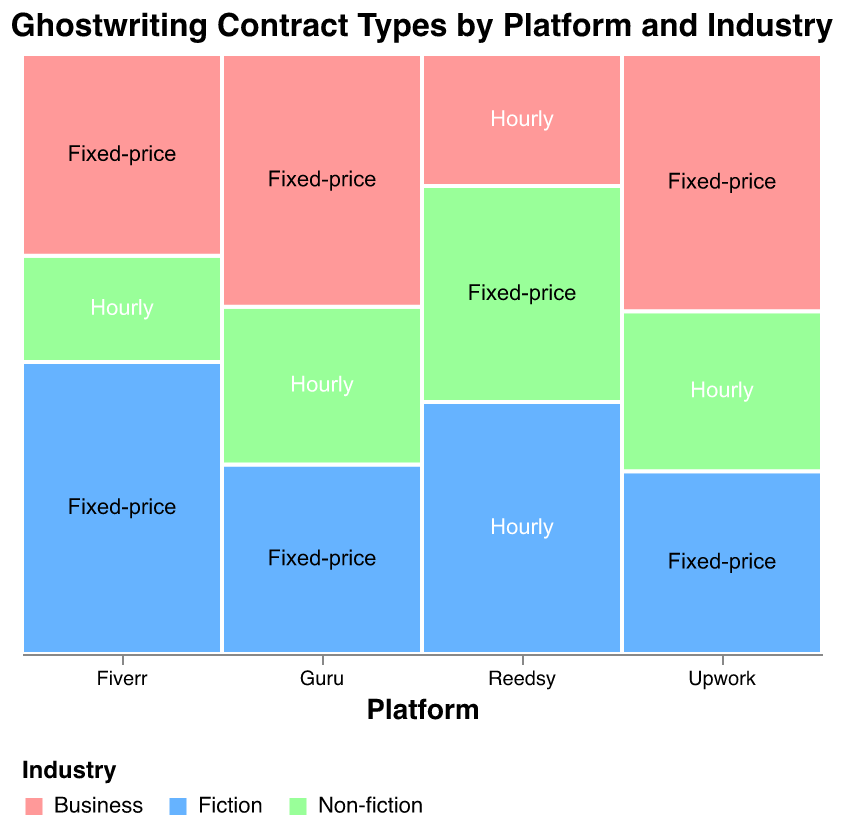Which platform has the highest number of Fixed-price contracts in the Fiction industry? Look at the rectangles representing Fixed-price contracts within the Fiction industry for each platform. Fiverr has the largest rectangle.
Answer: Fiverr Which industry on Upwork has the highest frequency of Fixed-price contracts? Compare the rectangles for each industry within Upwork that represents Fixed-price contracts. The Business industry has the largest Fixed-price rectangle.
Answer: Business Do any platforms predominantly use Hourly contracts in the Business industry? Check the rectangles corresponding to Hourly contracts within the Business industry for each platform. None of the platforms predominantly use Hourly contracts in the Business industry; they all use Fixed-price.
Answer: No What is the total frequency of Fixed-price contracts in the Fiction industry across all platforms? Add the frequencies for Fixed-price contracts in the Fiction industry for Upwork (32), Fiverr (55), and Guru (30). 32 + 55 + 30 = 117
Answer: 117 Which platform has the most balanced distribution of contract types across different industries in terms of visual appearance? Look at each platform and compare the sizes of the rectangles within. Reedsy appears to have a more balanced distribution between Hourly and Fixed-price across different industries.
Answer: Reedsy How does the frequency of Fixed-price contracts in Business on Fiverr compare to the same type of contract on Upwork? Compare the size of the Fixed-price rectangle in the Business industry between Fiverr and Upwork. Fiverr has a smaller rectangle (38) compared to Upwork (45).
Answer: Upwork has more Which platform and industry combination has the lowest frequency for Hourly contracts? Look at all the Hourly contracts and compare their sizes to determine the smallest. Fiverr's Non-fiction Hourly contract has the smallest rectangle with a frequency of 20.
Answer: Fiverr, Non-fiction Are Non-fiction contracts more frequently Hourly or Fixed-price across all platforms? Compare the total frequencies of Hourly and Fixed-price contracts in the Non-fiction industry. Non-fiction has 28 (Upwork) + 20 (Fiverr) + 25 (Guru) = 73 for Hourly, and 36 (Reedsy) for Fixed-price, so Hourly is more frequent.
Answer: Hourly Which platform uses Hourly contracts the least in the Fiction industry? Compare the Hourly contracts in the Fiction industry across platforms. Guru and Fiverr have no Hourly contracts in Fiction; Upwork is one of the platforms that don't.
Answer: Upwork What percentage of Guru's contracts in the Business industry are Fixed-price? Calculate the percentage for Fixed-price contracts out of the total for Guru in the Business industry. Business Fixed-price for Guru is 40, and the total is (30 + 25 + 40) = 95. So, (40/95) * 100 = 42.1%.
Answer: 42.1% 